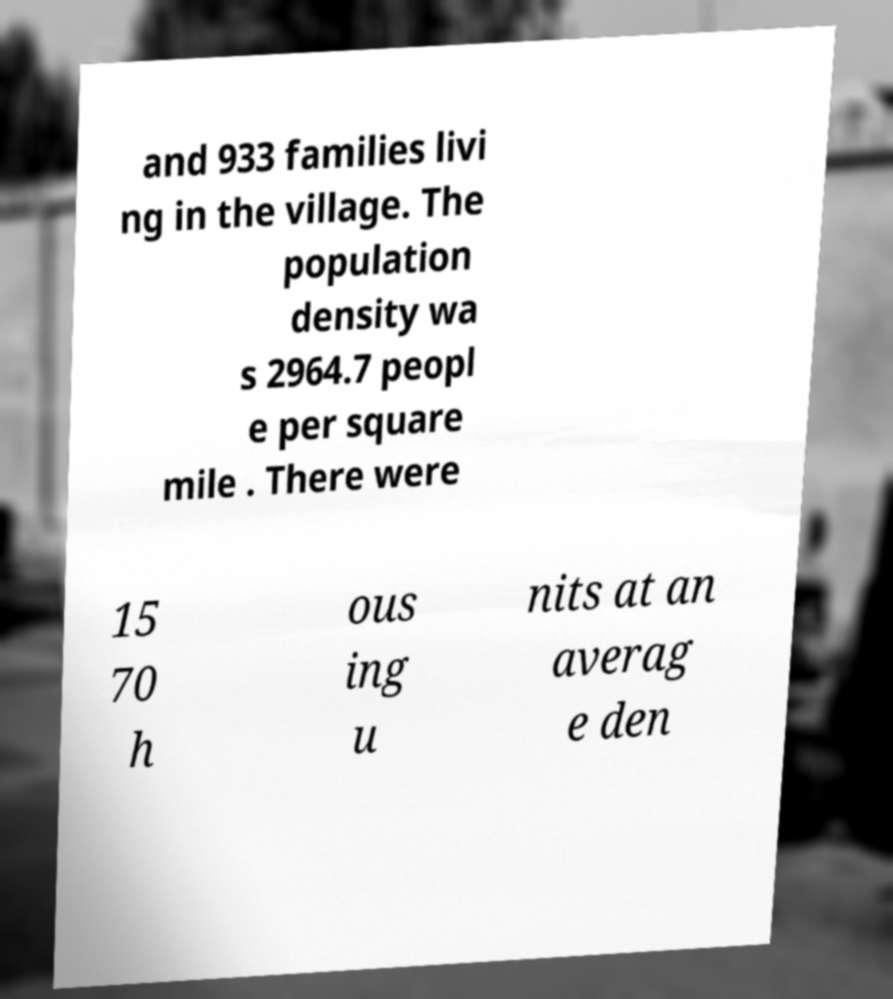What messages or text are displayed in this image? I need them in a readable, typed format. and 933 families livi ng in the village. The population density wa s 2964.7 peopl e per square mile . There were 15 70 h ous ing u nits at an averag e den 